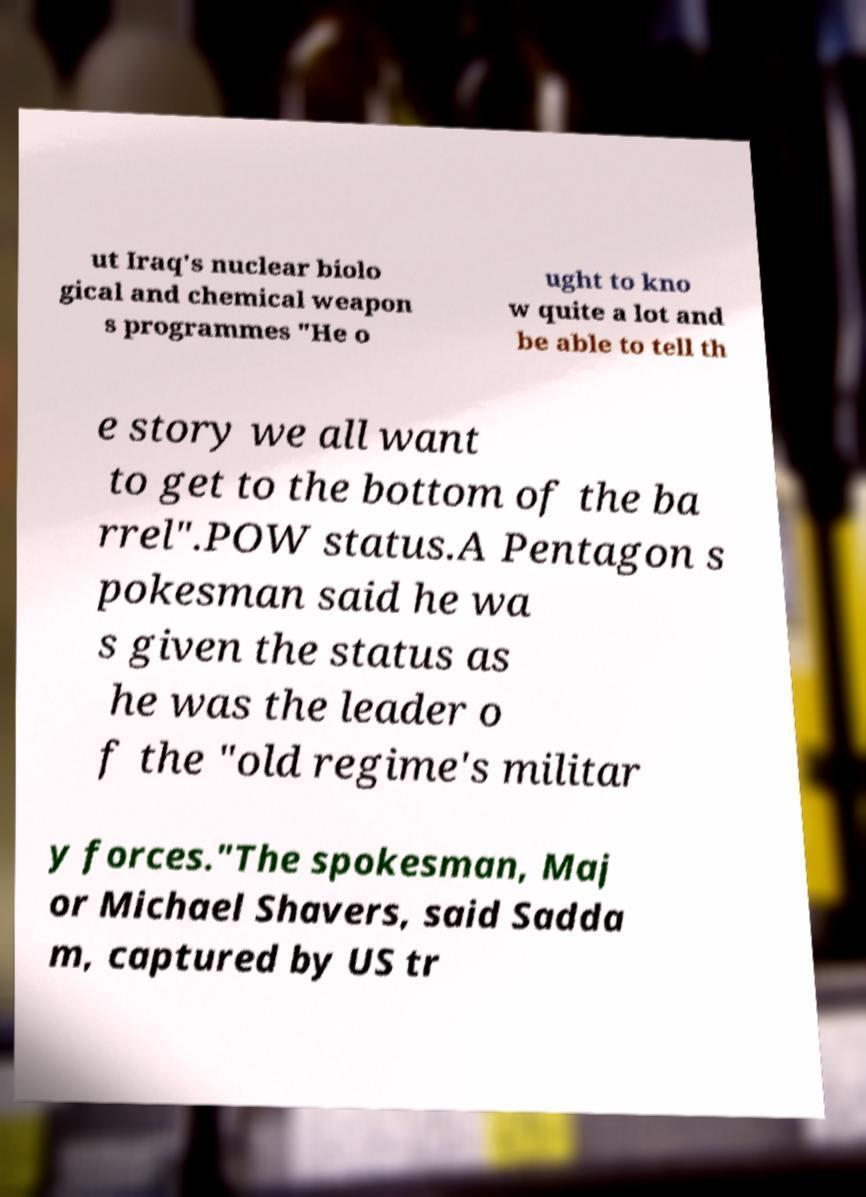There's text embedded in this image that I need extracted. Can you transcribe it verbatim? ut Iraq's nuclear biolo gical and chemical weapon s programmes "He o ught to kno w quite a lot and be able to tell th e story we all want to get to the bottom of the ba rrel".POW status.A Pentagon s pokesman said he wa s given the status as he was the leader o f the "old regime's militar y forces."The spokesman, Maj or Michael Shavers, said Sadda m, captured by US tr 